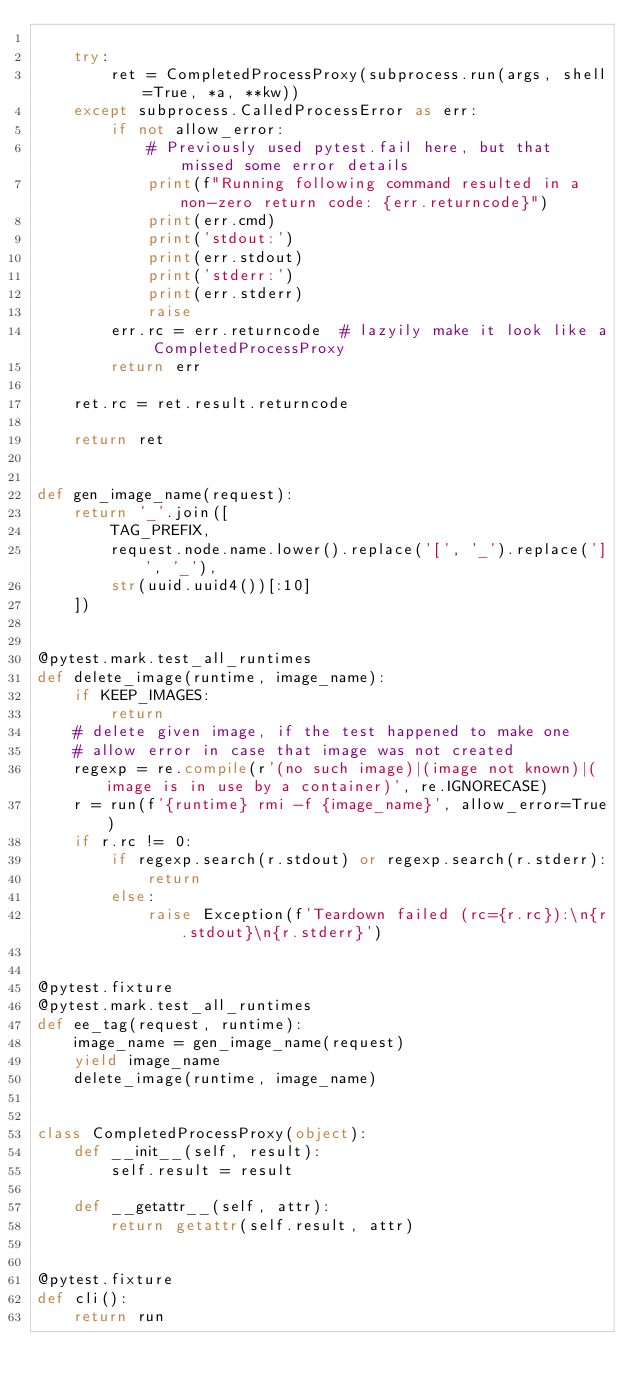Convert code to text. <code><loc_0><loc_0><loc_500><loc_500><_Python_>
    try:
        ret = CompletedProcessProxy(subprocess.run(args, shell=True, *a, **kw))
    except subprocess.CalledProcessError as err:
        if not allow_error:
            # Previously used pytest.fail here, but that missed some error details
            print(f"Running following command resulted in a non-zero return code: {err.returncode}")
            print(err.cmd)
            print('stdout:')
            print(err.stdout)
            print('stderr:')
            print(err.stderr)
            raise
        err.rc = err.returncode  # lazyily make it look like a CompletedProcessProxy
        return err

    ret.rc = ret.result.returncode

    return ret


def gen_image_name(request):
    return '_'.join([
        TAG_PREFIX,
        request.node.name.lower().replace('[', '_').replace(']', '_'),
        str(uuid.uuid4())[:10]
    ])


@pytest.mark.test_all_runtimes
def delete_image(runtime, image_name):
    if KEEP_IMAGES:
        return
    # delete given image, if the test happened to make one
    # allow error in case that image was not created
    regexp = re.compile(r'(no such image)|(image not known)|(image is in use by a container)', re.IGNORECASE)
    r = run(f'{runtime} rmi -f {image_name}', allow_error=True)
    if r.rc != 0:
        if regexp.search(r.stdout) or regexp.search(r.stderr):
            return
        else:
            raise Exception(f'Teardown failed (rc={r.rc}):\n{r.stdout}\n{r.stderr}')


@pytest.fixture
@pytest.mark.test_all_runtimes
def ee_tag(request, runtime):
    image_name = gen_image_name(request)
    yield image_name
    delete_image(runtime, image_name)


class CompletedProcessProxy(object):
    def __init__(self, result):
        self.result = result

    def __getattr__(self, attr):
        return getattr(self.result, attr)


@pytest.fixture
def cli():
    return run
</code> 